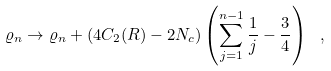Convert formula to latex. <formula><loc_0><loc_0><loc_500><loc_500>\varrho _ { n } \rightarrow \varrho _ { n } + ( 4 C _ { 2 } ( R ) - 2 N _ { c } ) \left ( \sum _ { j = 1 } ^ { n - 1 } \frac { 1 } { j } - \frac { 3 } { 4 } \right ) \ ,</formula> 